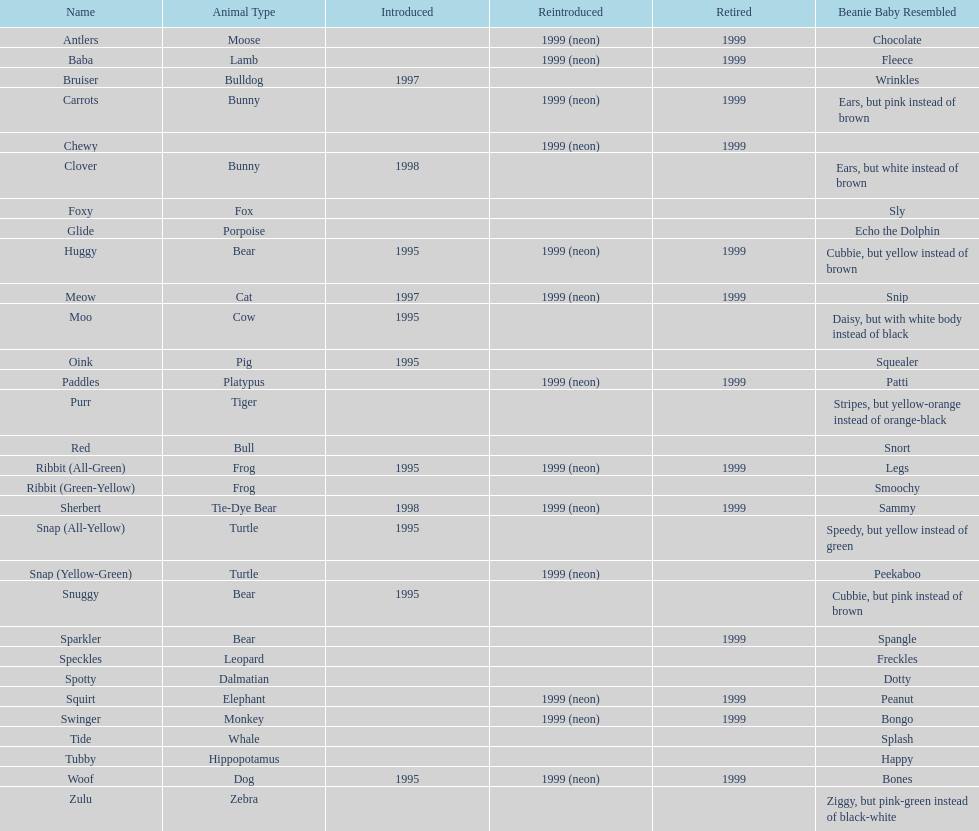In what year were the first pillow pals introduced? 1995. 